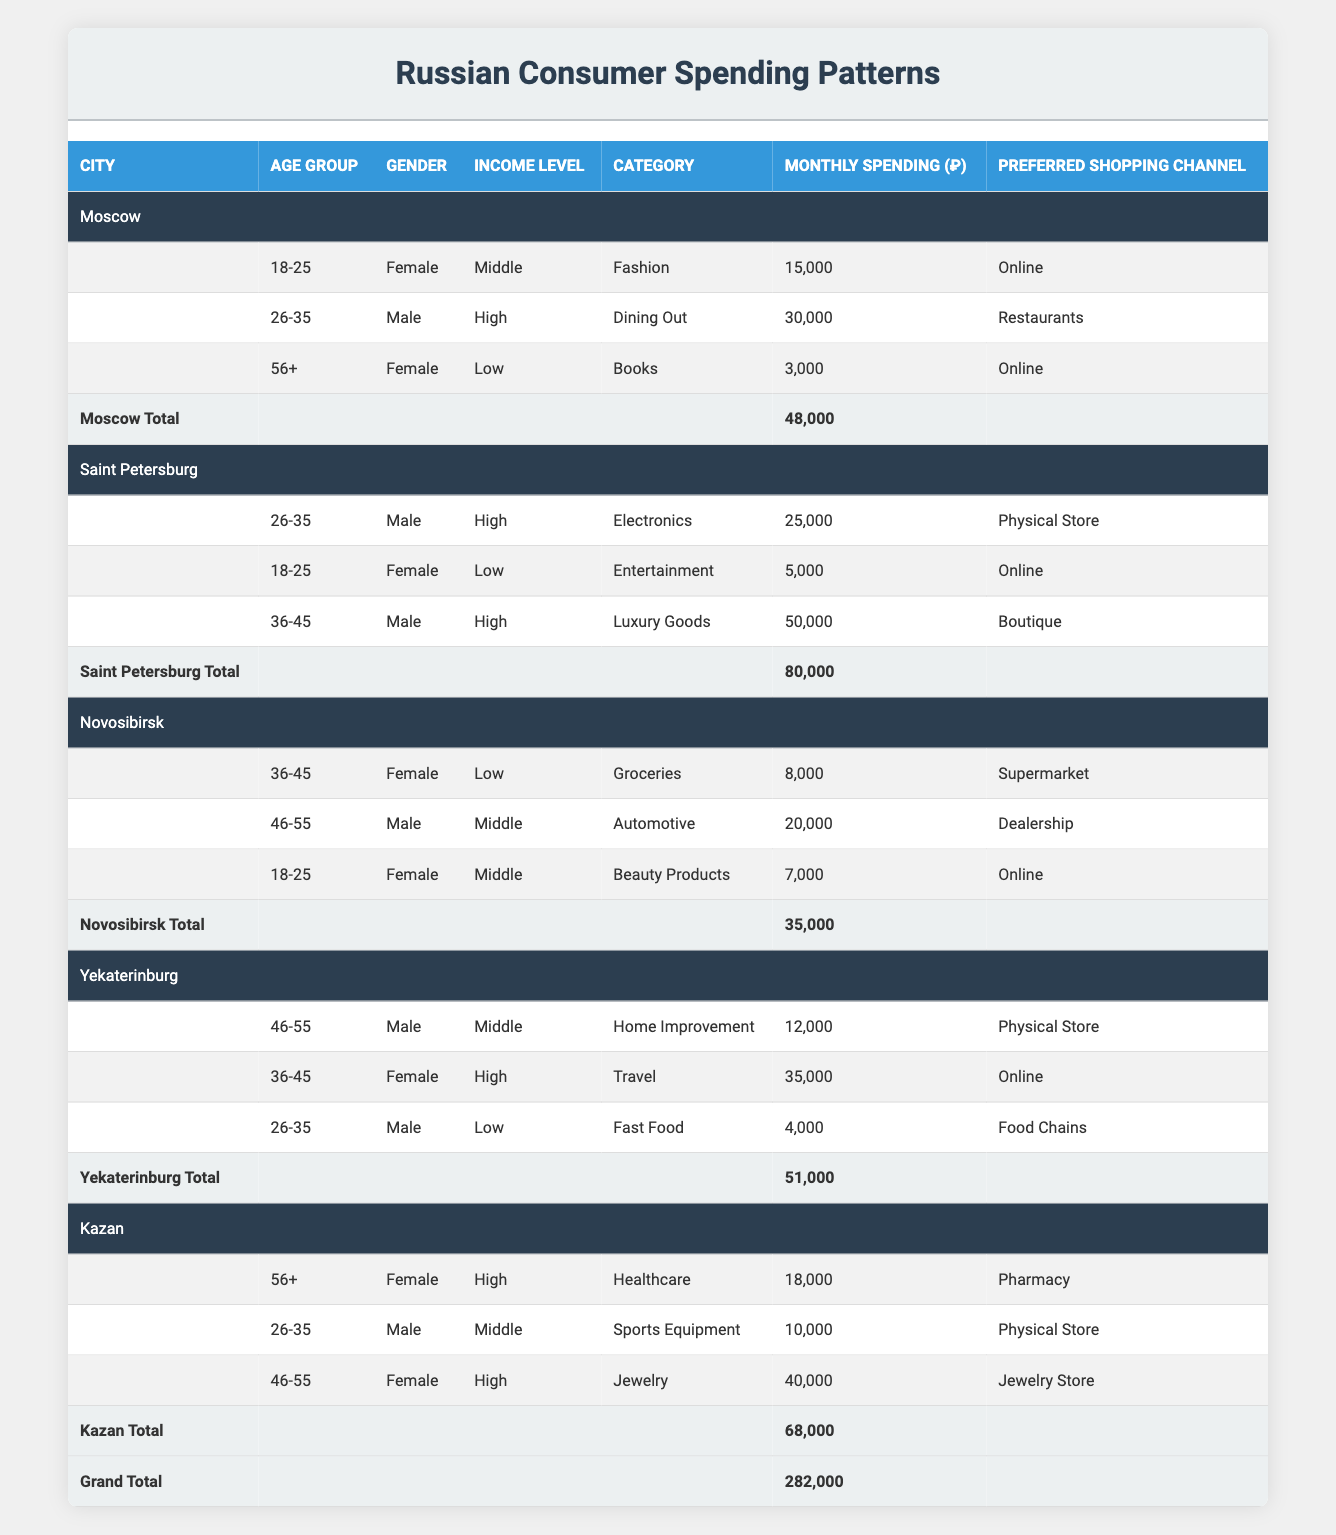What is the total monthly spending in Moscow? The table shows the monthly spending for three different age groups in Moscow: 15,000, 30,000, and 3,000. Adding these values together gives 15,000 + 30,000 + 3,000 = 48,000.
Answer: 48,000 Which shopping channel is preferred by the 18-25 year old female consumers in Moscow? According to the table, the 18-25 year old female consumers in Moscow prefer the Online shopping channel for Fashion, as shown in the respective row.
Answer: Online Is the monthly spending for male consumers in Saint Petersburg higher than that in Moscow? In Saint Petersburg, the male consumers have spending values of 25,000 (Electronics) and 50,000 (Luxury Goods), totaling 75,000. In contrast, the male consumers in Moscow spend 30,000 (Dining Out). Therefore, 75,000 is higher than 30,000.
Answer: Yes What is the total monthly spending for female consumers aged 46-55 across all cities? The table lists two amounts for female consumers in the 46-55 age group: 12,000 in Yekaterinburg (Home Improvement) and 40,000 in Kazan (Jewelry). Adding these two amounts gives 12,000 + 40,000 = 52,000.
Answer: 52,000 Do male consumers in Novosibirsk spend more on Automotive or do female consumers in Novosibirsk spend more on Beauty Products? Male consumers in Novosibirsk spend 20,000 on Automotive, while female consumers spend 7,000 on Beauty Products. Since 20,000 is more than 7,000, the male consumers spend more.
Answer: No In which city do the highest average spending values occur for high-income male consumers? The table shows high-income male consumers spending 25,000 (Saint Petersburg, Electronics), 30,000 (Moscow, Dining Out), and 50,000 (Saint Petersburg, Luxury Goods). So the highest values are 25,000 and 50,000 in Saint Petersburg, leading to an average calculation of (25,000 + 50,000)/2 = 37,500, while no high-income male spending exists in other cities.
Answer: Saint Petersburg Is the preferred shopping channel for high-income female consumers in Kazan the same as in Novosibirsk? The high-income female consumers in Kazan prefer the Pharmacy for Healthcare, while in Novosibirsk, there are no high-income females, leading to a No answer.
Answer: No What is the total monthly spending across all the cities displayed in the table? The table shows total spending as 48,000 (Moscow) + 80,000 (Saint Petersburg) + 35,000 (Novosibirsk) + 51,000 (Yekaterinburg) + 68,000 (Kazan), which sums to 282,000.
Answer: 282,000 